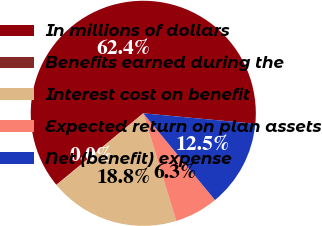<chart> <loc_0><loc_0><loc_500><loc_500><pie_chart><fcel>In millions of dollars<fcel>Benefits earned during the<fcel>Interest cost on benefit<fcel>Expected return on plan assets<fcel>Net (benefit) expense<nl><fcel>62.43%<fcel>0.03%<fcel>18.75%<fcel>6.27%<fcel>12.51%<nl></chart> 